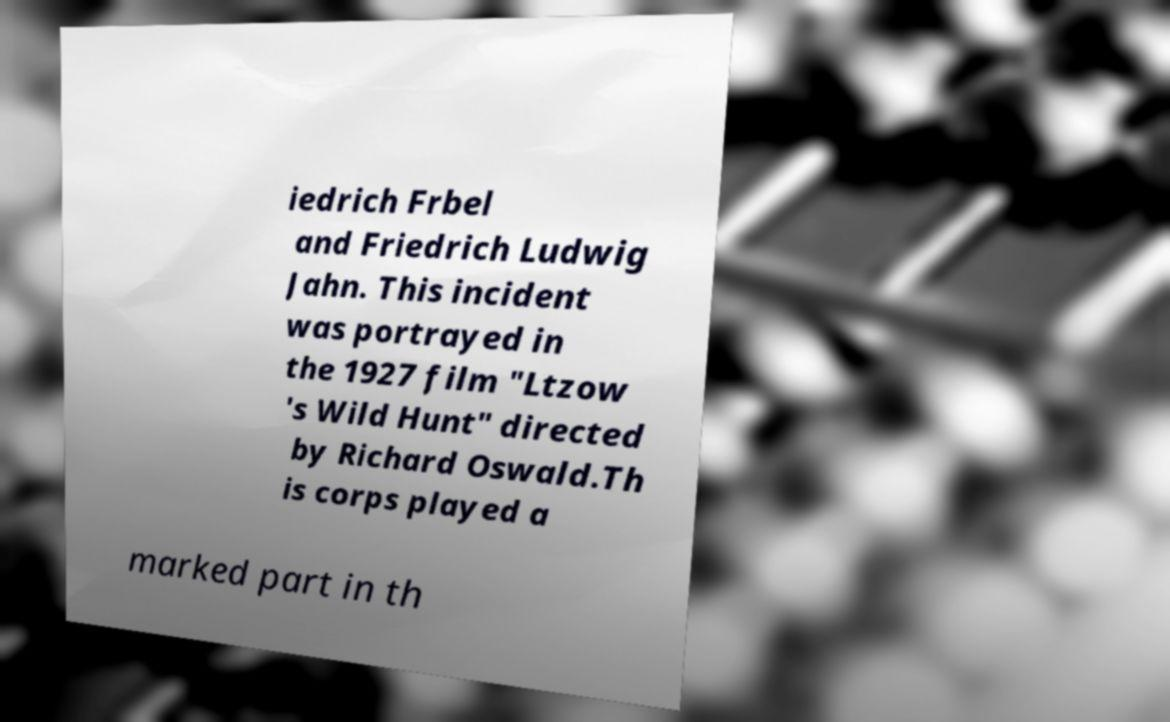Please identify and transcribe the text found in this image. iedrich Frbel and Friedrich Ludwig Jahn. This incident was portrayed in the 1927 film "Ltzow 's Wild Hunt" directed by Richard Oswald.Th is corps played a marked part in th 